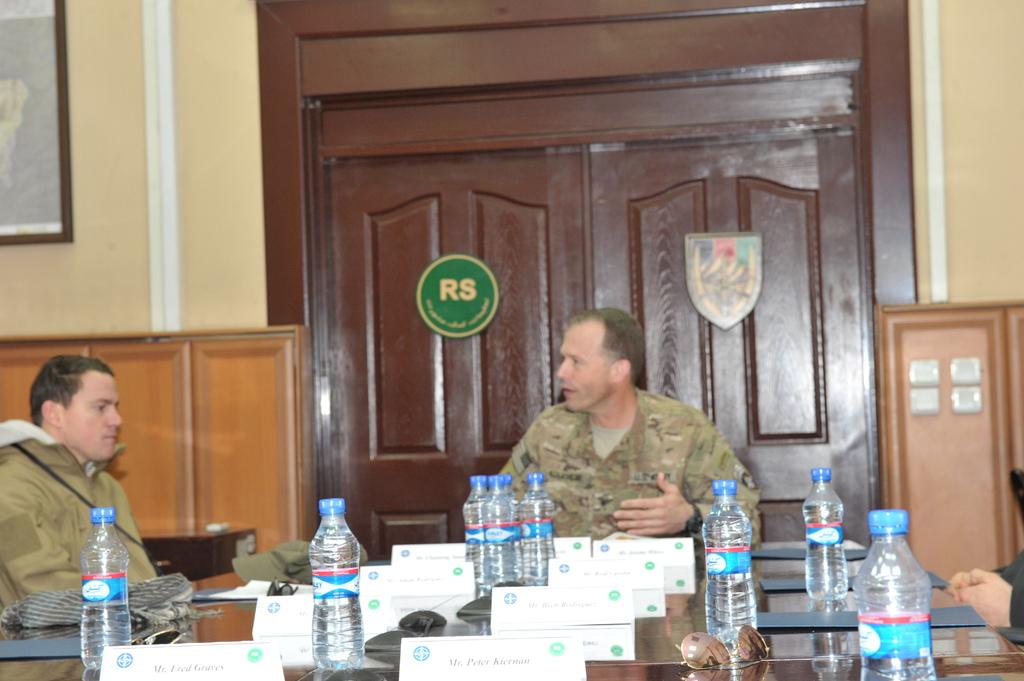What is on the green sign?
Provide a short and direct response. Rs. What does the name card on the first left say?
Keep it short and to the point. Unanswerable. 